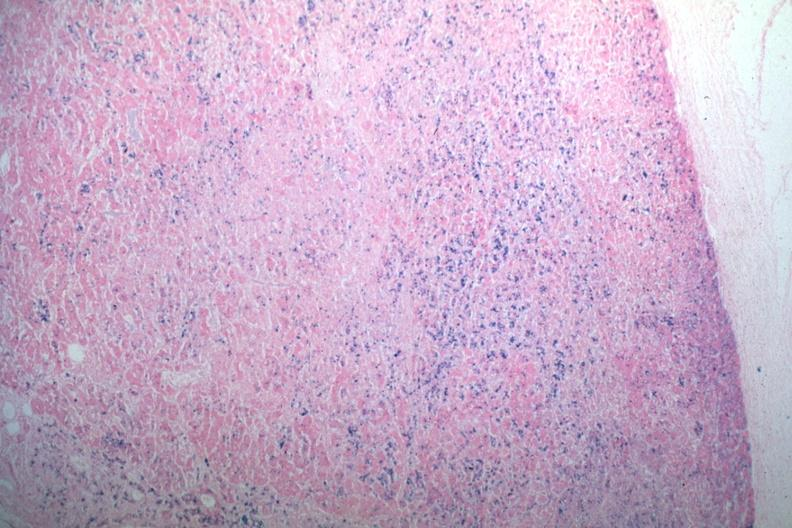where is this part in the figure?
Answer the question using a single word or phrase. Endocrine system 